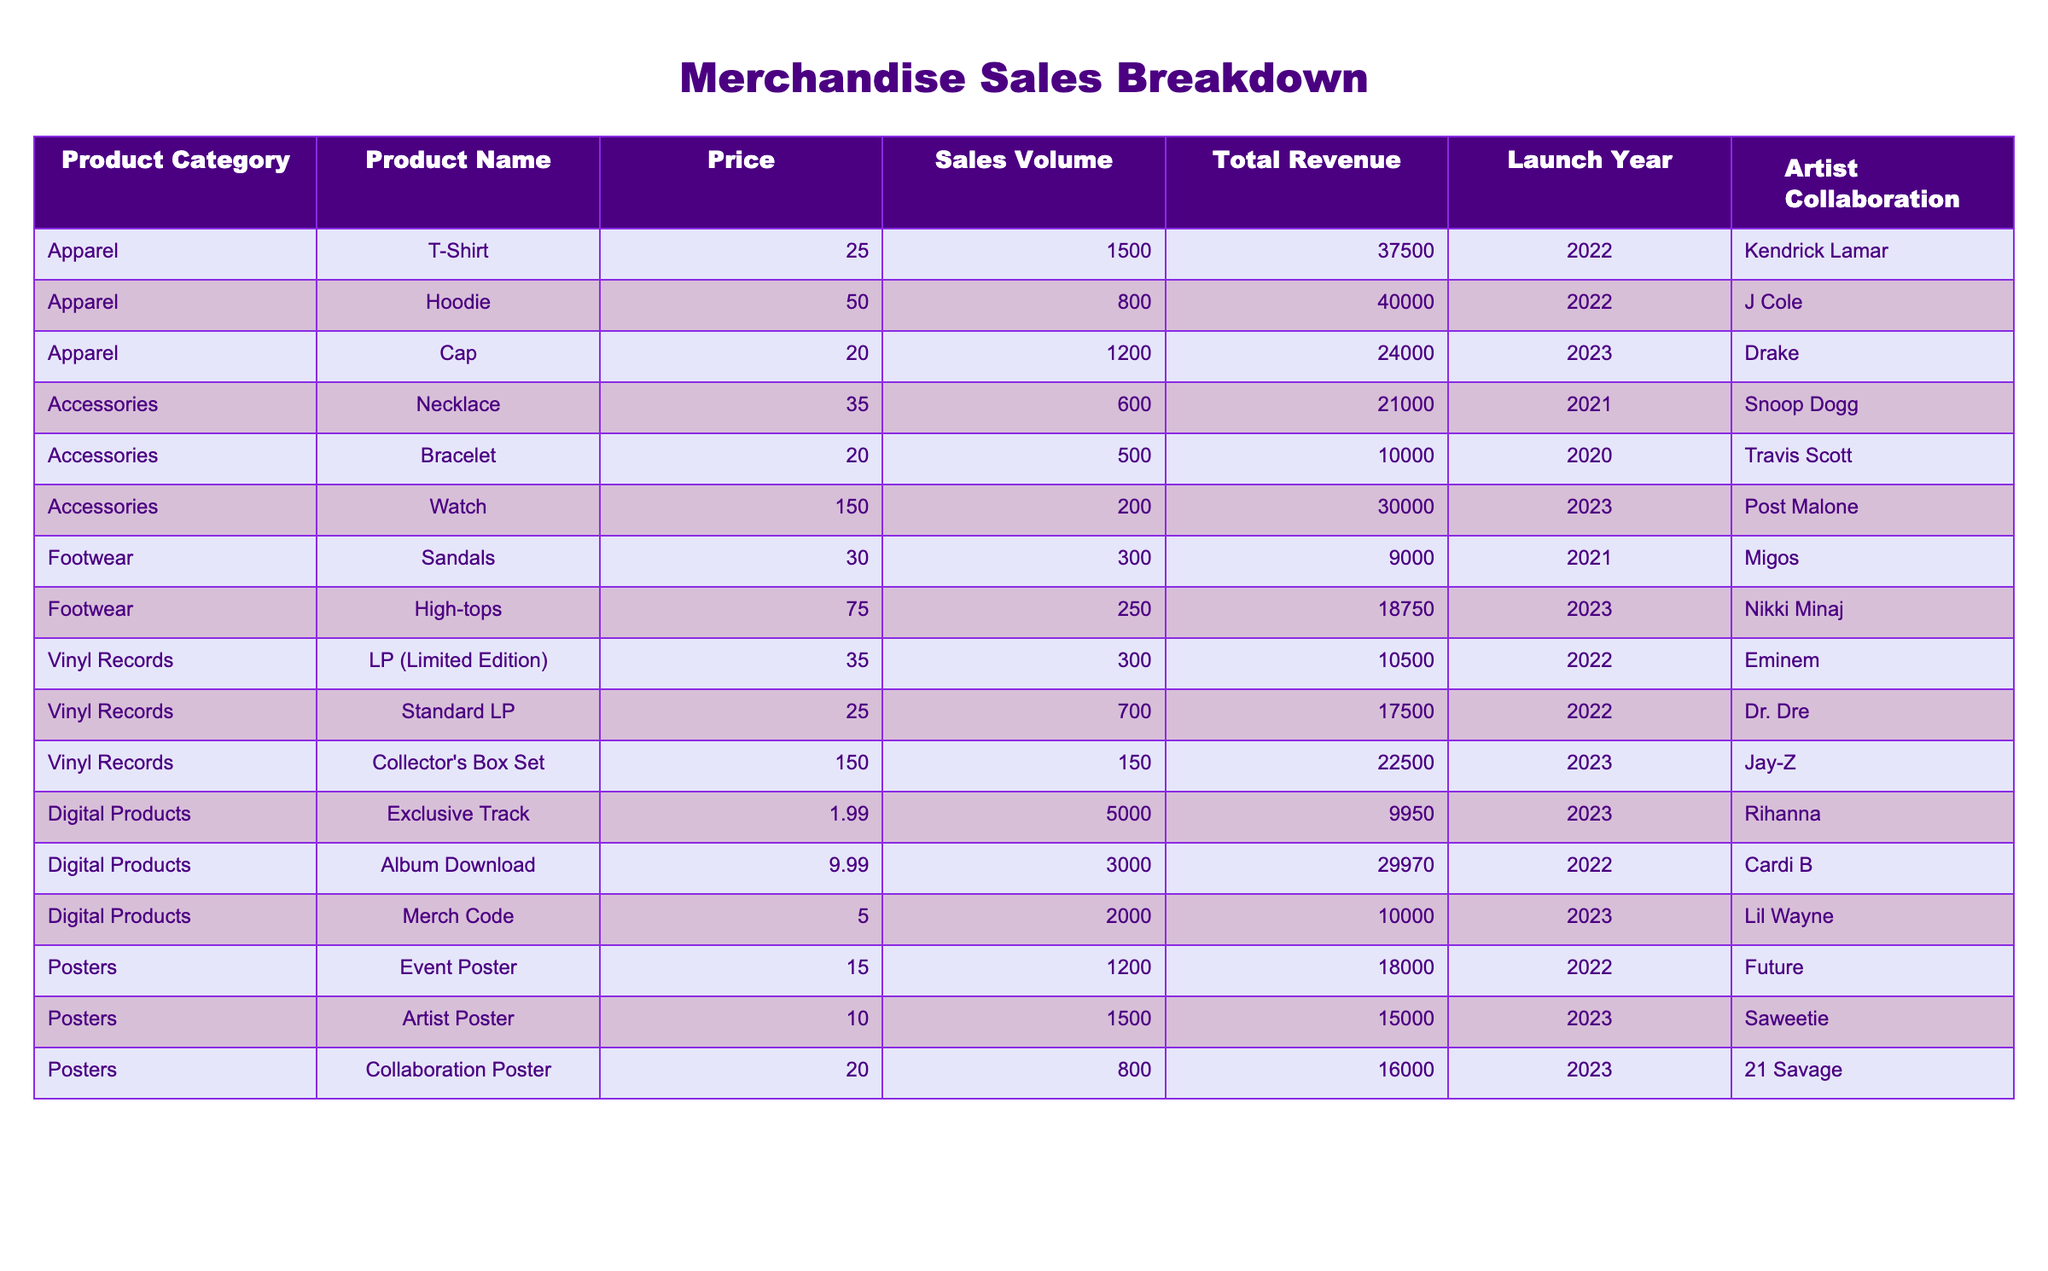What is the total revenue generated from all Apparel products? To find the total revenue from Apparel, I need to look at the "Total Revenue" column for each Apparel product: T-Shirt ($37,500) + Hoodie ($40,000) + Cap ($24,000) = $101,500.
Answer: $101,500 Which product sold the highest number of units? To determine the product with the highest sales volume, I compare the "Sales Volume" values for each product. The Exclusive Track has the highest volume at 5,000 units.
Answer: Exclusive Track What is the average price of Digital Products? To calculate the average price of Digital Products, I add up the prices: $1.99 + $9.99 + $5.00 = $16.98, then divide by the number of Digital Products (3): $16.98 / 3 = $5.66.
Answer: $5.66 Did the Collector's Box Set generate more revenue than the Standard LP? The Collector's Box Set generated $22,500, while the Standard LP generated $17,500. Since $22,500 is greater than $17,500, the statement is true.
Answer: Yes What percentage of total revenue comes from Vinyl Records? First, I sum the total revenue from Vinyl Records: $10,500 + $17,500 + $22,500 = $50,500. Next, I find the total revenue from all products: $37500 + $40000 + $24000 + $21000 + $10000 + $30000 + $9000 + $18750 + $10500 + $17500 + $22500 + $9950 + $29970 + $10000 + $18000 + $15000 + $16000 = $365,000. The percentage is ($50,500 / $365,000) * 100 = 13.84%.
Answer: 13.84% Which product category has the highest average sales volume? I calculate the average sales volume for each category: Apparel: (1500 + 800 + 1200) / 3 = 1333.33; Accessories: (600 + 500 + 200) / 3 = 433.33; Footwear: (300 + 250) / 2 = 275; Vinyl Records: (300 + 700 + 150) / 3 = 383.33; Digital Products: (5000 + 3000 + 2000) / 3 = 3333.33; Posters: (1200 + 1500 + 800) / 3 = 1166.67. Digital Products has the highest average sales volume at 3333.33 units.
Answer: Digital Products How many products have an Artist Collaboration with Drake? I look for products with "Drake" listed under the Artist Collaboration column. There is 1 product, the Cap.
Answer: 1 